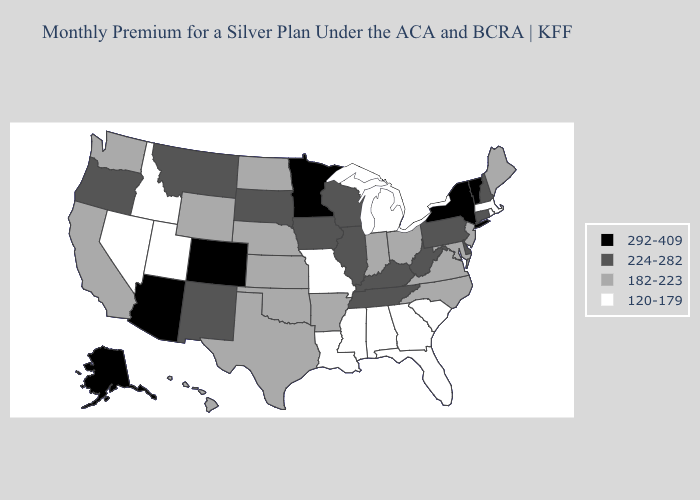Among the states that border Kansas , which have the lowest value?
Quick response, please. Missouri. What is the lowest value in states that border Pennsylvania?
Answer briefly. 182-223. Does Indiana have the highest value in the USA?
Concise answer only. No. Among the states that border Washington , which have the highest value?
Concise answer only. Oregon. What is the value of Montana?
Be succinct. 224-282. Name the states that have a value in the range 292-409?
Answer briefly. Alaska, Arizona, Colorado, Minnesota, New York, Vermont. What is the highest value in the USA?
Concise answer only. 292-409. What is the value of North Dakota?
Concise answer only. 182-223. Name the states that have a value in the range 120-179?
Be succinct. Alabama, Florida, Georgia, Idaho, Louisiana, Massachusetts, Michigan, Mississippi, Missouri, Nevada, Rhode Island, South Carolina, Utah. Which states hav the highest value in the Northeast?
Give a very brief answer. New York, Vermont. What is the value of Kentucky?
Be succinct. 224-282. Among the states that border Minnesota , does North Dakota have the highest value?
Concise answer only. No. Which states have the lowest value in the South?
Give a very brief answer. Alabama, Florida, Georgia, Louisiana, Mississippi, South Carolina. Is the legend a continuous bar?
Answer briefly. No. What is the value of Michigan?
Write a very short answer. 120-179. 